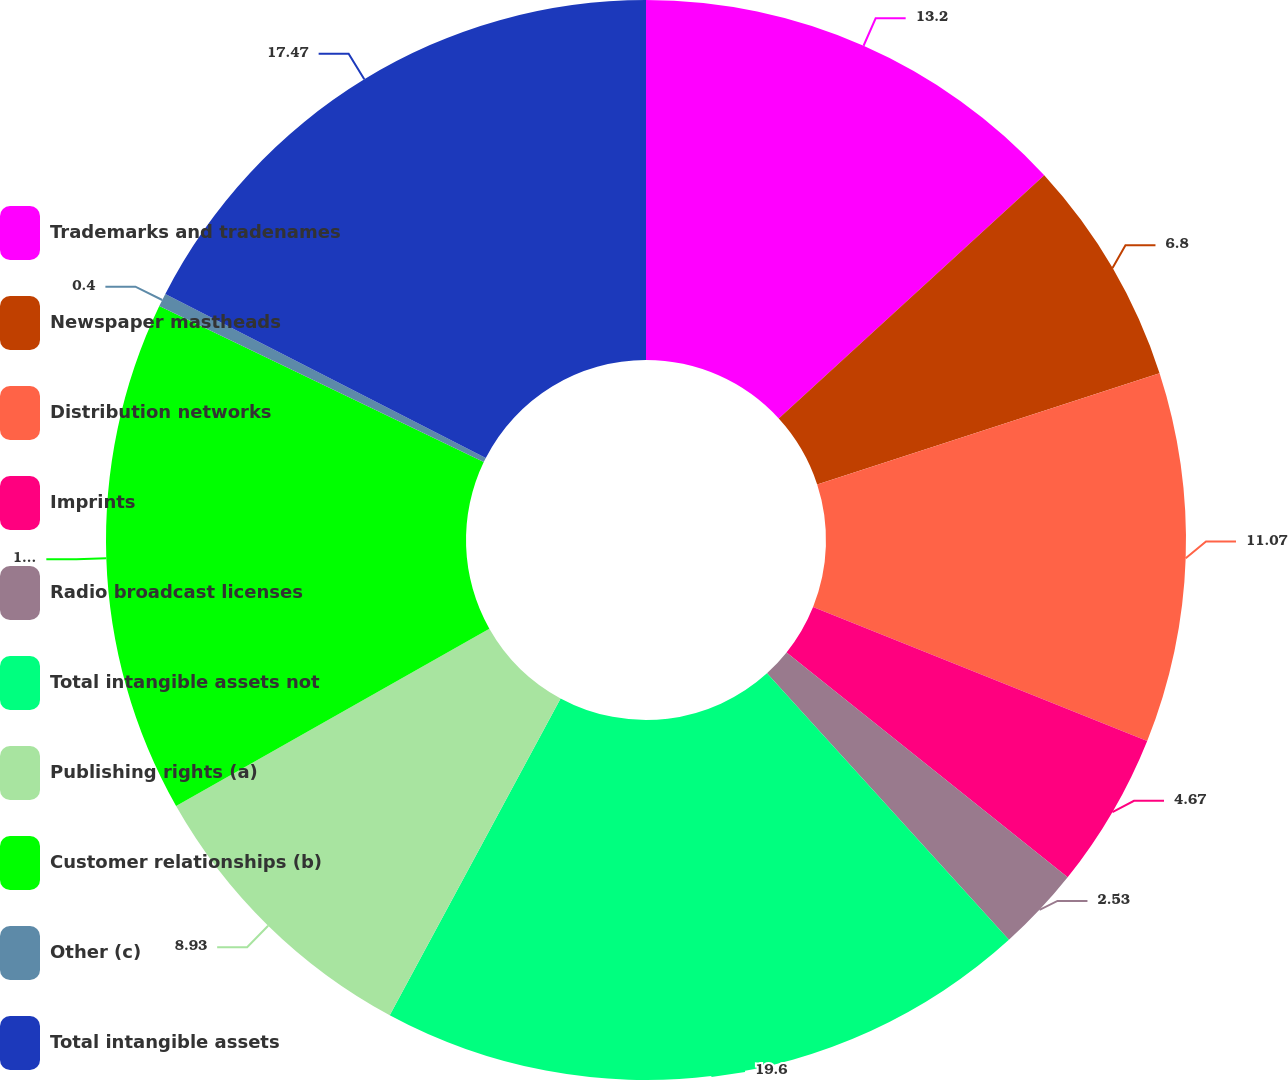Convert chart to OTSL. <chart><loc_0><loc_0><loc_500><loc_500><pie_chart><fcel>Trademarks and tradenames<fcel>Newspaper mastheads<fcel>Distribution networks<fcel>Imprints<fcel>Radio broadcast licenses<fcel>Total intangible assets not<fcel>Publishing rights (a)<fcel>Customer relationships (b)<fcel>Other (c)<fcel>Total intangible assets<nl><fcel>13.2%<fcel>6.8%<fcel>11.07%<fcel>4.67%<fcel>2.53%<fcel>19.6%<fcel>8.93%<fcel>15.33%<fcel>0.4%<fcel>17.47%<nl></chart> 